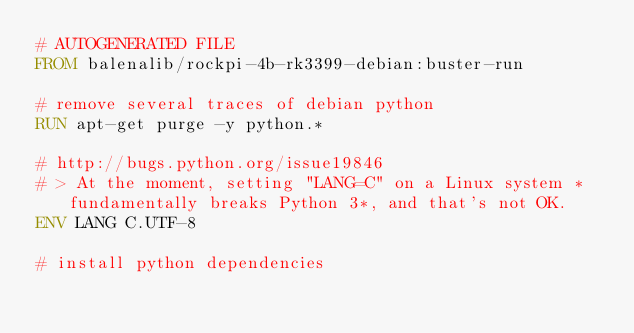Convert code to text. <code><loc_0><loc_0><loc_500><loc_500><_Dockerfile_># AUTOGENERATED FILE
FROM balenalib/rockpi-4b-rk3399-debian:buster-run

# remove several traces of debian python
RUN apt-get purge -y python.*

# http://bugs.python.org/issue19846
# > At the moment, setting "LANG=C" on a Linux system *fundamentally breaks Python 3*, and that's not OK.
ENV LANG C.UTF-8

# install python dependencies</code> 